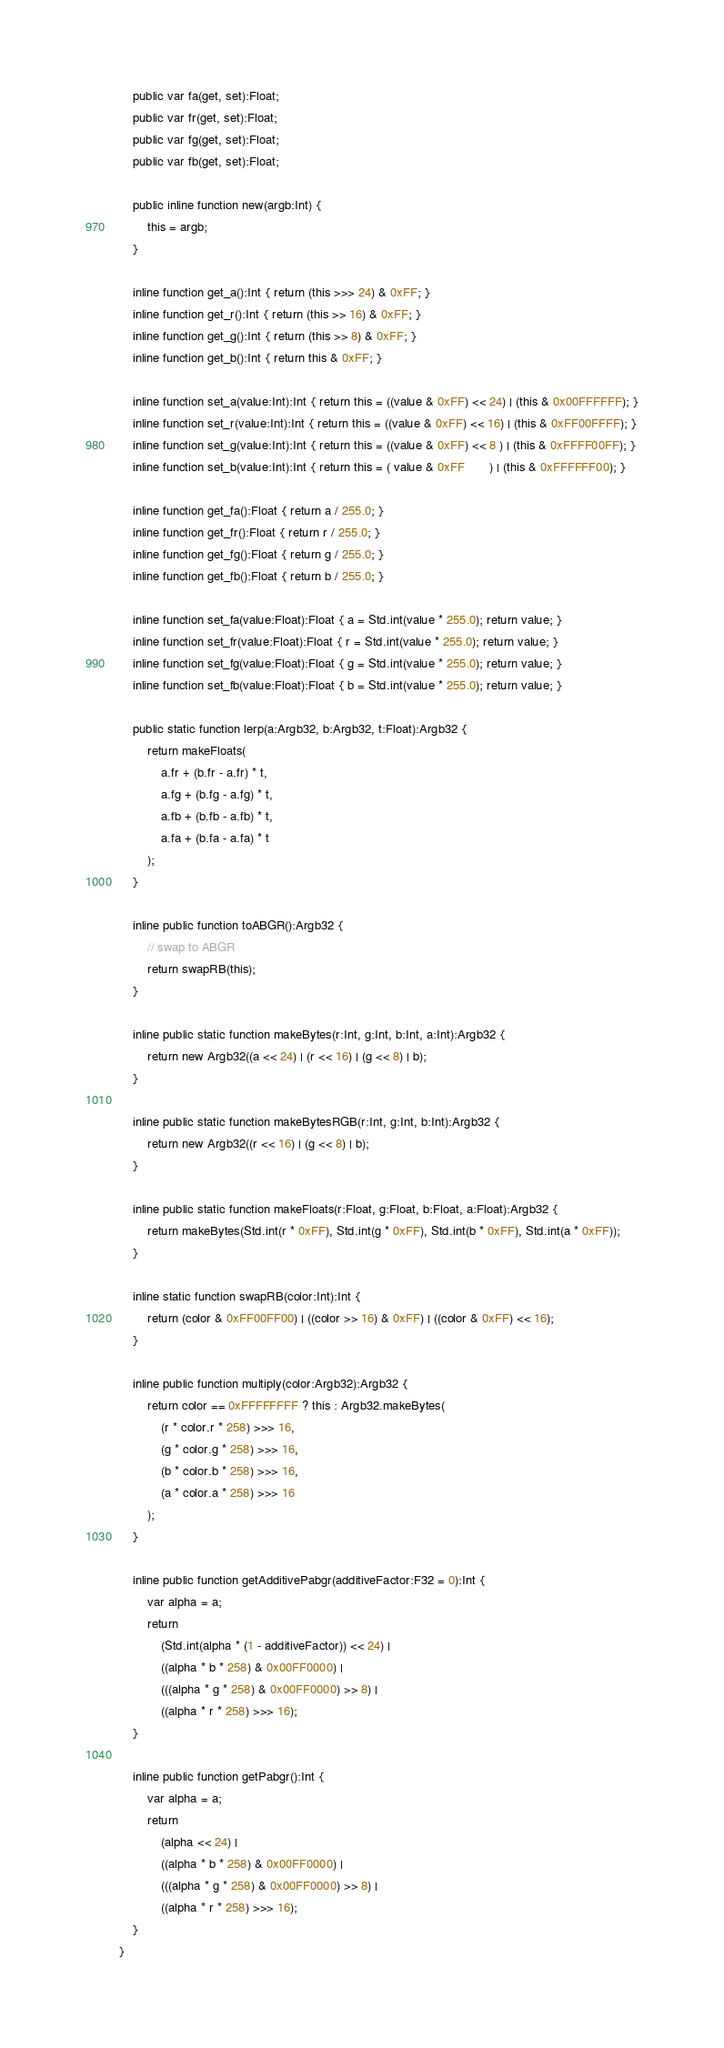Convert code to text. <code><loc_0><loc_0><loc_500><loc_500><_Haxe_>
	public var fa(get, set):Float;
	public var fr(get, set):Float;
	public var fg(get, set):Float;
	public var fb(get, set):Float;

	public inline function new(argb:Int) {
		this = argb;
	}

	inline function get_a():Int { return (this >>> 24) & 0xFF; }
	inline function get_r():Int { return (this >> 16) & 0xFF; }
	inline function get_g():Int { return (this >> 8) & 0xFF; }
	inline function get_b():Int { return this & 0xFF; }

	inline function set_a(value:Int):Int { return this = ((value & 0xFF) << 24) | (this & 0x00FFFFFF); }
	inline function set_r(value:Int):Int { return this = ((value & 0xFF) << 16) | (this & 0xFF00FFFF); }
	inline function set_g(value:Int):Int { return this = ((value & 0xFF) << 8 ) | (this & 0xFFFF00FF); }
	inline function set_b(value:Int):Int { return this = ( value & 0xFF       ) | (this & 0xFFFFFF00); }

	inline function get_fa():Float { return a / 255.0; }
	inline function get_fr():Float { return r / 255.0; }
	inline function get_fg():Float { return g / 255.0; }
	inline function get_fb():Float { return b / 255.0; }

	inline function set_fa(value:Float):Float { a = Std.int(value * 255.0); return value; }
	inline function set_fr(value:Float):Float { r = Std.int(value * 255.0); return value; }
	inline function set_fg(value:Float):Float { g = Std.int(value * 255.0); return value; }
	inline function set_fb(value:Float):Float { b = Std.int(value * 255.0); return value; }

	public static function lerp(a:Argb32, b:Argb32, t:Float):Argb32 {
		return makeFloats(
			a.fr + (b.fr - a.fr) * t,
			a.fg + (b.fg - a.fg) * t,
			a.fb + (b.fb - a.fb) * t,
			a.fa + (b.fa - a.fa) * t
		);
	}

	inline public function toABGR():Argb32 {
		// swap to ABGR
		return swapRB(this);
	}

	inline public static function makeBytes(r:Int, g:Int, b:Int, a:Int):Argb32 {
		return new Argb32((a << 24) | (r << 16) | (g << 8) | b);
	}

	inline public static function makeBytesRGB(r:Int, g:Int, b:Int):Argb32 {
		return new Argb32((r << 16) | (g << 8) | b);
	}

	inline public static function makeFloats(r:Float, g:Float, b:Float, a:Float):Argb32 {
		return makeBytes(Std.int(r * 0xFF), Std.int(g * 0xFF), Std.int(b * 0xFF), Std.int(a * 0xFF));
	}

	inline static function swapRB(color:Int):Int {
		return (color & 0xFF00FF00) | ((color >> 16) & 0xFF) | ((color & 0xFF) << 16);
	}

	inline public function multiply(color:Argb32):Argb32 {
		return color == 0xFFFFFFFF ? this : Argb32.makeBytes(
			(r * color.r * 258) >>> 16,
			(g * color.g * 258) >>> 16,
			(b * color.b * 258) >>> 16,
			(a * color.a * 258) >>> 16
		);
	}

	inline public function getAdditivePabgr(additiveFactor:F32 = 0):Int {
		var alpha = a;
		return
			(Std.int(alpha * (1 - additiveFactor)) << 24) |
			((alpha * b * 258) & 0x00FF0000) |
			(((alpha * g * 258) & 0x00FF0000) >> 8) |
			((alpha * r * 258) >>> 16);
	}

	inline public function getPabgr():Int {
		var alpha = a;
		return
			(alpha << 24) |
			((alpha * b * 258) & 0x00FF0000) |
			(((alpha * g * 258) & 0x00FF0000) >> 8) |
			((alpha * r * 258) >>> 16);
	}
}
</code> 